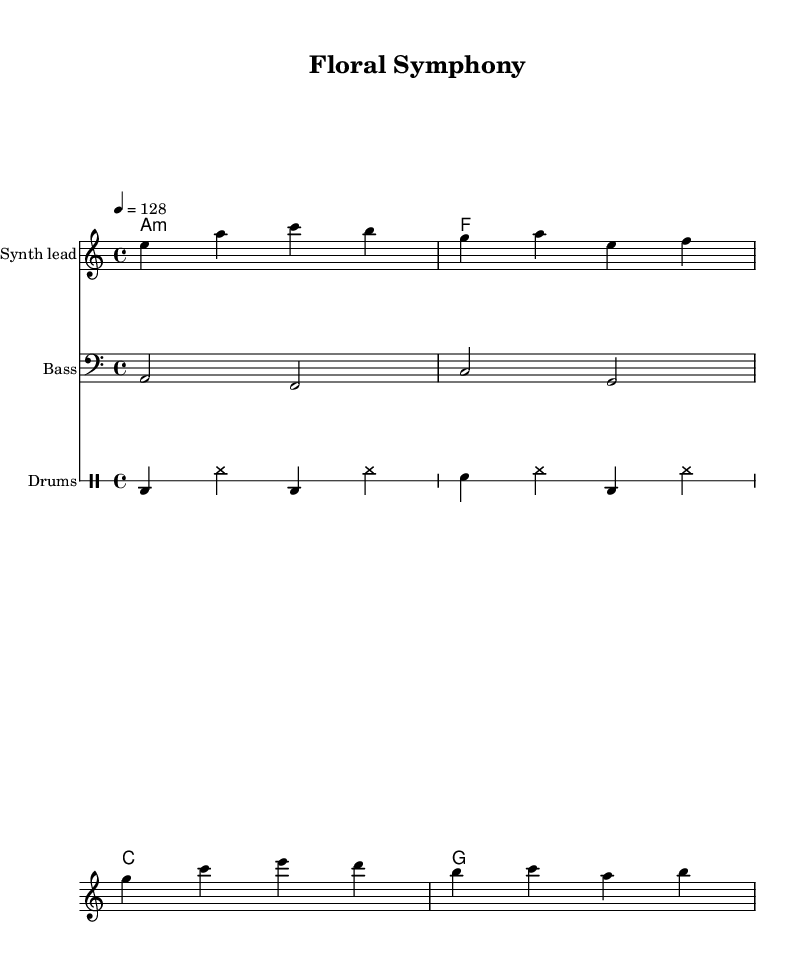What is the key signature of this music? The key signature is A minor, which has no sharps or flats and is indicated at the beginning of the staff.
Answer: A minor What is the time signature of this music? The time signature is 4/4, meaning there are four beats in a measure and the quarter note gets one beat. This is indicated at the beginning of the score.
Answer: 4/4 What tempo marking is used in this score? The tempo marking is 128 beats per minute, which is indicated with the symbol '4 = 128' right after the time signature.
Answer: 128 How many measures are there in the melody? There are four measures in the melody, easily counted by the vertical lines that indicate the end of each measure.
Answer: 4 Which type of percussion instrument is indicated in the sheet music? The sheet music includes a bass drum and snare drum as indicated by the symbols in the drummode section.
Answer: Bass drum and snare What is the harmonic structure of this piece? The harmonic structure consists of the chords A minor, F major, C major, and G major, as indicated in the chord mode section.
Answer: A minor, F major, C major, G major What makes this piece a melodic house composition? The piece incorporates a steady 4/4 beat, synthesizer melodies, and layered instrumentation typical of the house genre, showcasing a rhythmic and melodic complexity.
Answer: Steady 4/4 beat, synthesizer melodies 